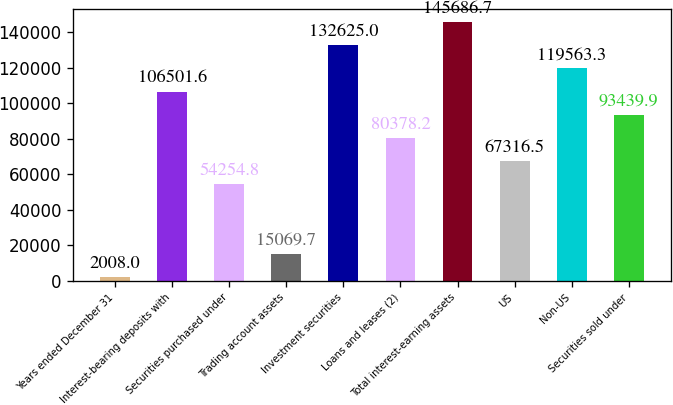<chart> <loc_0><loc_0><loc_500><loc_500><bar_chart><fcel>Years ended December 31<fcel>Interest-bearing deposits with<fcel>Securities purchased under<fcel>Trading account assets<fcel>Investment securities<fcel>Loans and leases (2)<fcel>Total interest-earning assets<fcel>US<fcel>Non-US<fcel>Securities sold under<nl><fcel>2008<fcel>106502<fcel>54254.8<fcel>15069.7<fcel>132625<fcel>80378.2<fcel>145687<fcel>67316.5<fcel>119563<fcel>93439.9<nl></chart> 